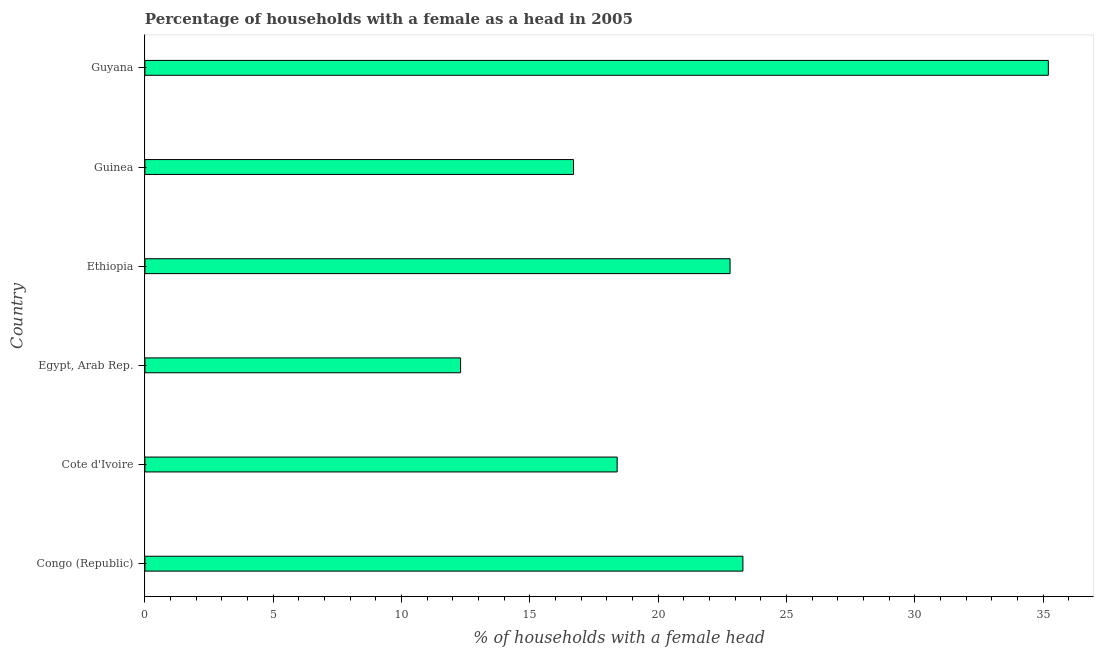What is the title of the graph?
Your answer should be compact. Percentage of households with a female as a head in 2005. What is the label or title of the X-axis?
Your response must be concise. % of households with a female head. Across all countries, what is the maximum number of female supervised households?
Your response must be concise. 35.2. Across all countries, what is the minimum number of female supervised households?
Keep it short and to the point. 12.3. In which country was the number of female supervised households maximum?
Your answer should be compact. Guyana. In which country was the number of female supervised households minimum?
Keep it short and to the point. Egypt, Arab Rep. What is the sum of the number of female supervised households?
Ensure brevity in your answer.  128.7. What is the difference between the number of female supervised households in Cote d'Ivoire and Guinea?
Provide a succinct answer. 1.7. What is the average number of female supervised households per country?
Offer a terse response. 21.45. What is the median number of female supervised households?
Offer a very short reply. 20.6. What is the ratio of the number of female supervised households in Congo (Republic) to that in Egypt, Arab Rep.?
Keep it short and to the point. 1.89. Is the number of female supervised households in Congo (Republic) less than that in Ethiopia?
Make the answer very short. No. Is the difference between the number of female supervised households in Egypt, Arab Rep. and Guinea greater than the difference between any two countries?
Keep it short and to the point. No. What is the difference between the highest and the lowest number of female supervised households?
Offer a terse response. 22.9. In how many countries, is the number of female supervised households greater than the average number of female supervised households taken over all countries?
Offer a very short reply. 3. Are all the bars in the graph horizontal?
Provide a short and direct response. Yes. How many countries are there in the graph?
Give a very brief answer. 6. What is the difference between two consecutive major ticks on the X-axis?
Provide a short and direct response. 5. What is the % of households with a female head of Congo (Republic)?
Your answer should be compact. 23.3. What is the % of households with a female head of Cote d'Ivoire?
Offer a terse response. 18.4. What is the % of households with a female head in Ethiopia?
Offer a very short reply. 22.8. What is the % of households with a female head of Guyana?
Make the answer very short. 35.2. What is the difference between the % of households with a female head in Cote d'Ivoire and Guinea?
Keep it short and to the point. 1.7. What is the difference between the % of households with a female head in Cote d'Ivoire and Guyana?
Provide a succinct answer. -16.8. What is the difference between the % of households with a female head in Egypt, Arab Rep. and Guinea?
Make the answer very short. -4.4. What is the difference between the % of households with a female head in Egypt, Arab Rep. and Guyana?
Offer a terse response. -22.9. What is the difference between the % of households with a female head in Ethiopia and Guyana?
Provide a short and direct response. -12.4. What is the difference between the % of households with a female head in Guinea and Guyana?
Keep it short and to the point. -18.5. What is the ratio of the % of households with a female head in Congo (Republic) to that in Cote d'Ivoire?
Your answer should be compact. 1.27. What is the ratio of the % of households with a female head in Congo (Republic) to that in Egypt, Arab Rep.?
Give a very brief answer. 1.89. What is the ratio of the % of households with a female head in Congo (Republic) to that in Guinea?
Your answer should be compact. 1.4. What is the ratio of the % of households with a female head in Congo (Republic) to that in Guyana?
Offer a terse response. 0.66. What is the ratio of the % of households with a female head in Cote d'Ivoire to that in Egypt, Arab Rep.?
Give a very brief answer. 1.5. What is the ratio of the % of households with a female head in Cote d'Ivoire to that in Ethiopia?
Offer a very short reply. 0.81. What is the ratio of the % of households with a female head in Cote d'Ivoire to that in Guinea?
Offer a terse response. 1.1. What is the ratio of the % of households with a female head in Cote d'Ivoire to that in Guyana?
Give a very brief answer. 0.52. What is the ratio of the % of households with a female head in Egypt, Arab Rep. to that in Ethiopia?
Your answer should be very brief. 0.54. What is the ratio of the % of households with a female head in Egypt, Arab Rep. to that in Guinea?
Provide a short and direct response. 0.74. What is the ratio of the % of households with a female head in Egypt, Arab Rep. to that in Guyana?
Provide a succinct answer. 0.35. What is the ratio of the % of households with a female head in Ethiopia to that in Guinea?
Your answer should be very brief. 1.36. What is the ratio of the % of households with a female head in Ethiopia to that in Guyana?
Provide a succinct answer. 0.65. What is the ratio of the % of households with a female head in Guinea to that in Guyana?
Provide a succinct answer. 0.47. 